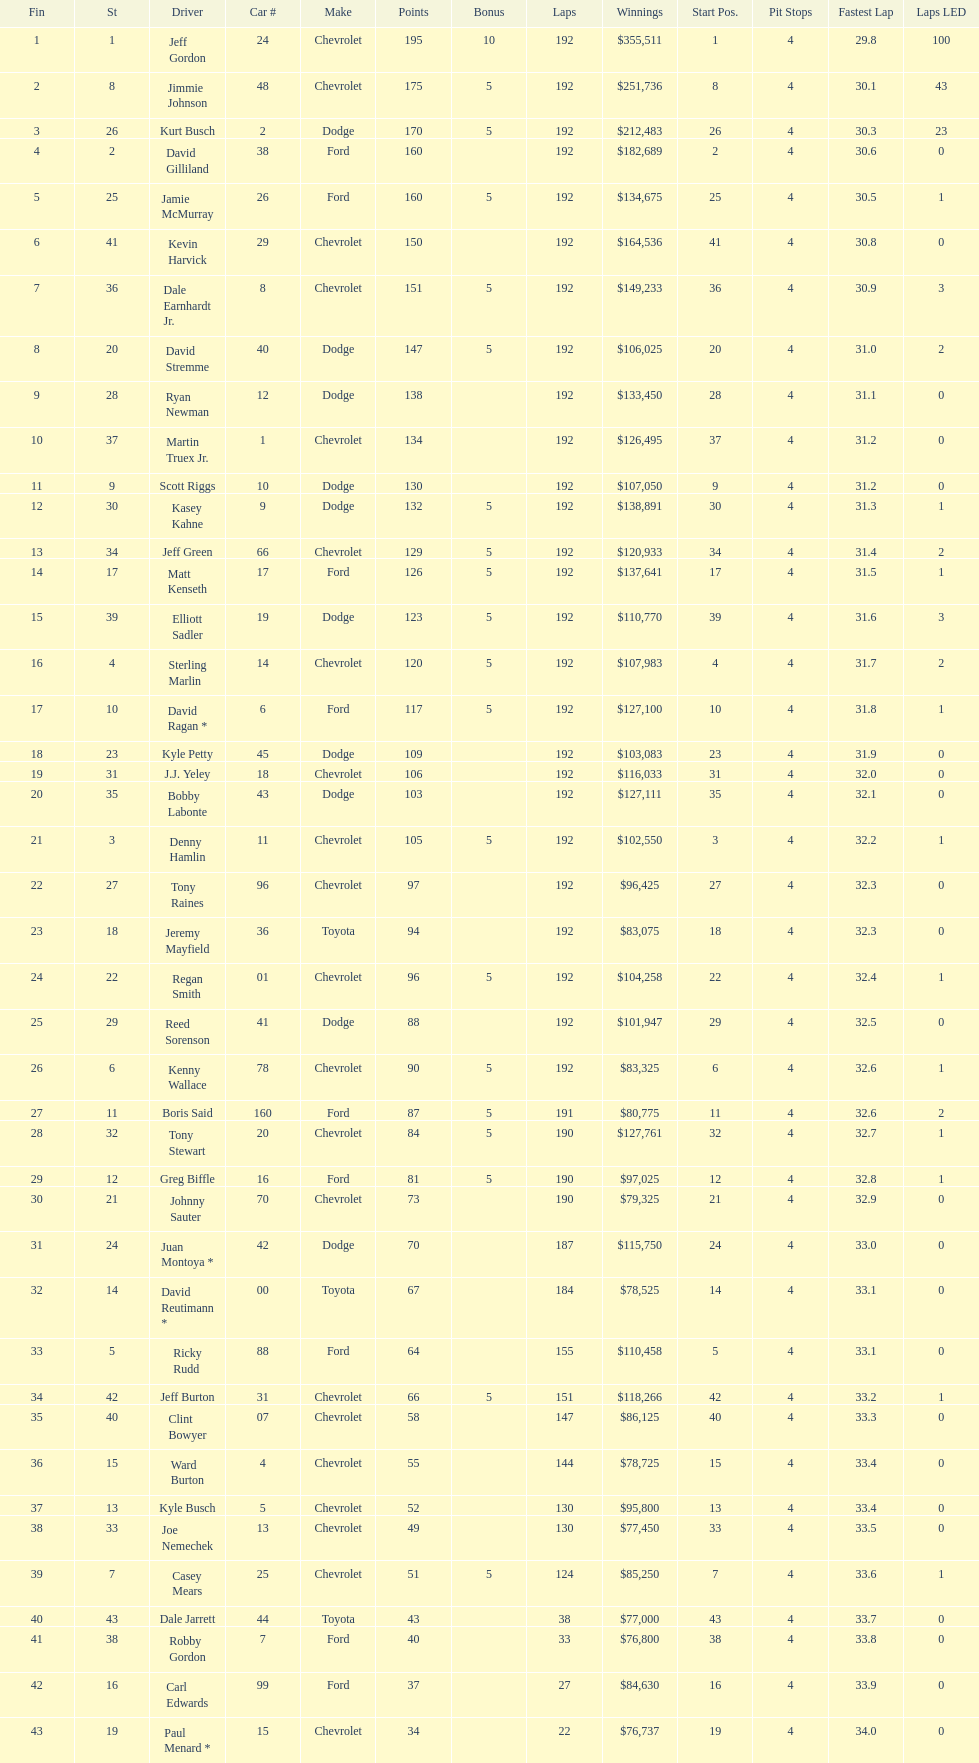How many race car drivers out of the 43 listed drove toyotas? 3. 